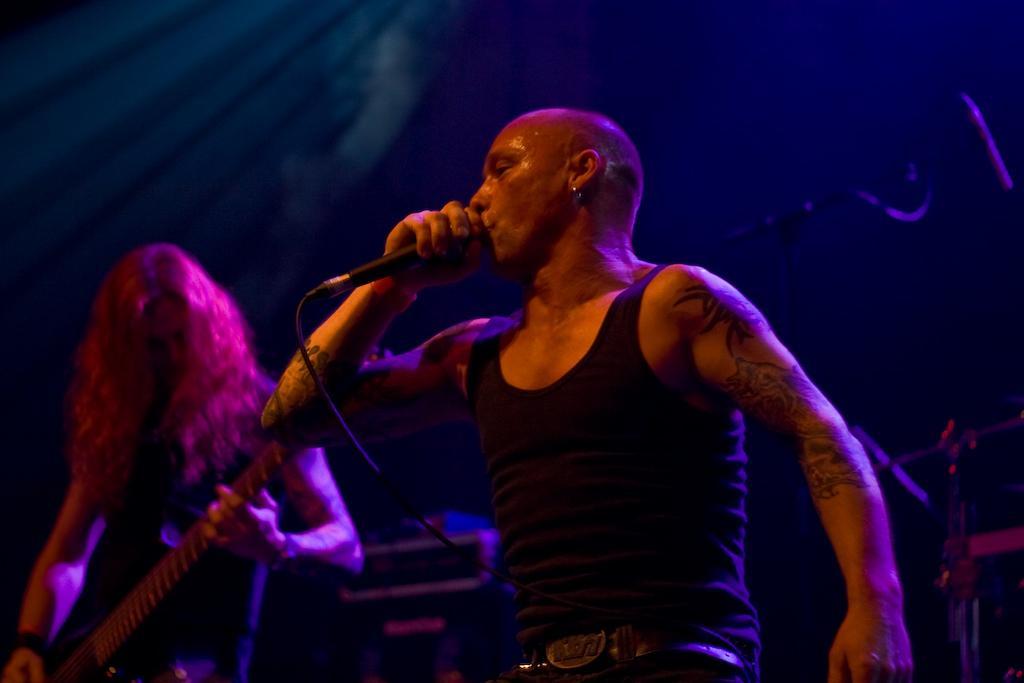Describe this image in one or two sentences. a person is singing, holding a microphone in his hand. he is wearing a black waist and a belt. left to him there is another person playing guitar. behind them there is microphone. the background is black in color. pink light is falling on them. 